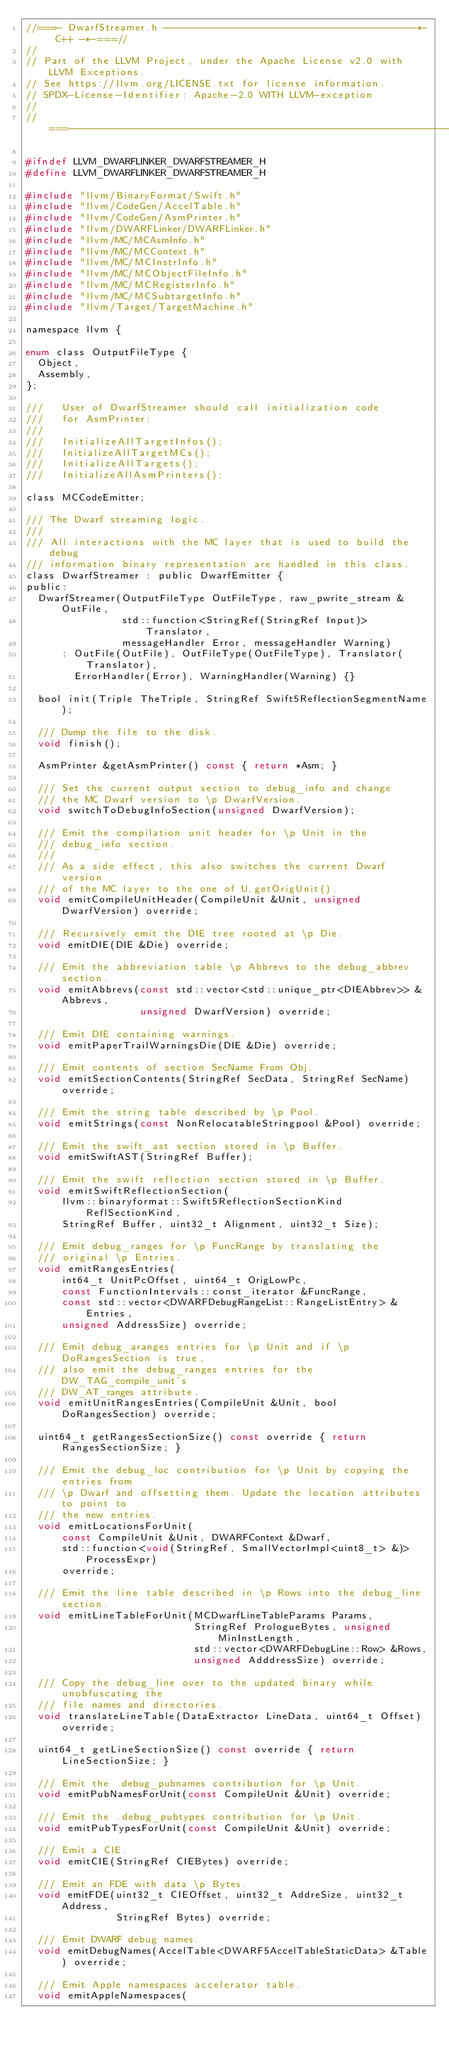Convert code to text. <code><loc_0><loc_0><loc_500><loc_500><_C_>//===- DwarfStreamer.h ------------------------------------------*- C++ -*-===//
//
// Part of the LLVM Project, under the Apache License v2.0 with LLVM Exceptions.
// See https://llvm.org/LICENSE.txt for license information.
// SPDX-License-Identifier: Apache-2.0 WITH LLVM-exception
//
//===----------------------------------------------------------------------===//

#ifndef LLVM_DWARFLINKER_DWARFSTREAMER_H
#define LLVM_DWARFLINKER_DWARFSTREAMER_H

#include "llvm/BinaryFormat/Swift.h"
#include "llvm/CodeGen/AccelTable.h"
#include "llvm/CodeGen/AsmPrinter.h"
#include "llvm/DWARFLinker/DWARFLinker.h"
#include "llvm/MC/MCAsmInfo.h"
#include "llvm/MC/MCContext.h"
#include "llvm/MC/MCInstrInfo.h"
#include "llvm/MC/MCObjectFileInfo.h"
#include "llvm/MC/MCRegisterInfo.h"
#include "llvm/MC/MCSubtargetInfo.h"
#include "llvm/Target/TargetMachine.h"

namespace llvm {

enum class OutputFileType {
  Object,
  Assembly,
};

///   User of DwarfStreamer should call initialization code
///   for AsmPrinter:
///
///   InitializeAllTargetInfos();
///   InitializeAllTargetMCs();
///   InitializeAllTargets();
///   InitializeAllAsmPrinters();

class MCCodeEmitter;

/// The Dwarf streaming logic.
///
/// All interactions with the MC layer that is used to build the debug
/// information binary representation are handled in this class.
class DwarfStreamer : public DwarfEmitter {
public:
  DwarfStreamer(OutputFileType OutFileType, raw_pwrite_stream &OutFile,
                std::function<StringRef(StringRef Input)> Translator,
                messageHandler Error, messageHandler Warning)
      : OutFile(OutFile), OutFileType(OutFileType), Translator(Translator),
        ErrorHandler(Error), WarningHandler(Warning) {}

  bool init(Triple TheTriple, StringRef Swift5ReflectionSegmentName);

  /// Dump the file to the disk.
  void finish();

  AsmPrinter &getAsmPrinter() const { return *Asm; }

  /// Set the current output section to debug_info and change
  /// the MC Dwarf version to \p DwarfVersion.
  void switchToDebugInfoSection(unsigned DwarfVersion);

  /// Emit the compilation unit header for \p Unit in the
  /// debug_info section.
  ///
  /// As a side effect, this also switches the current Dwarf version
  /// of the MC layer to the one of U.getOrigUnit().
  void emitCompileUnitHeader(CompileUnit &Unit, unsigned DwarfVersion) override;

  /// Recursively emit the DIE tree rooted at \p Die.
  void emitDIE(DIE &Die) override;

  /// Emit the abbreviation table \p Abbrevs to the debug_abbrev section.
  void emitAbbrevs(const std::vector<std::unique_ptr<DIEAbbrev>> &Abbrevs,
                   unsigned DwarfVersion) override;

  /// Emit DIE containing warnings.
  void emitPaperTrailWarningsDie(DIE &Die) override;

  /// Emit contents of section SecName From Obj.
  void emitSectionContents(StringRef SecData, StringRef SecName) override;

  /// Emit the string table described by \p Pool.
  void emitStrings(const NonRelocatableStringpool &Pool) override;

  /// Emit the swift_ast section stored in \p Buffer.
  void emitSwiftAST(StringRef Buffer);

  /// Emit the swift reflection section stored in \p Buffer.
  void emitSwiftReflectionSection(
      llvm::binaryformat::Swift5ReflectionSectionKind ReflSectionKind,
      StringRef Buffer, uint32_t Alignment, uint32_t Size);

  /// Emit debug_ranges for \p FuncRange by translating the
  /// original \p Entries.
  void emitRangesEntries(
      int64_t UnitPcOffset, uint64_t OrigLowPc,
      const FunctionIntervals::const_iterator &FuncRange,
      const std::vector<DWARFDebugRangeList::RangeListEntry> &Entries,
      unsigned AddressSize) override;

  /// Emit debug_aranges entries for \p Unit and if \p DoRangesSection is true,
  /// also emit the debug_ranges entries for the DW_TAG_compile_unit's
  /// DW_AT_ranges attribute.
  void emitUnitRangesEntries(CompileUnit &Unit, bool DoRangesSection) override;

  uint64_t getRangesSectionSize() const override { return RangesSectionSize; }

  /// Emit the debug_loc contribution for \p Unit by copying the entries from
  /// \p Dwarf and offsetting them. Update the location attributes to point to
  /// the new entries.
  void emitLocationsForUnit(
      const CompileUnit &Unit, DWARFContext &Dwarf,
      std::function<void(StringRef, SmallVectorImpl<uint8_t> &)> ProcessExpr)
      override;

  /// Emit the line table described in \p Rows into the debug_line section.
  void emitLineTableForUnit(MCDwarfLineTableParams Params,
                            StringRef PrologueBytes, unsigned MinInstLength,
                            std::vector<DWARFDebugLine::Row> &Rows,
                            unsigned AdddressSize) override;

  /// Copy the debug_line over to the updated binary while unobfuscating the
  /// file names and directories.
  void translateLineTable(DataExtractor LineData, uint64_t Offset) override;

  uint64_t getLineSectionSize() const override { return LineSectionSize; }

  /// Emit the .debug_pubnames contribution for \p Unit.
  void emitPubNamesForUnit(const CompileUnit &Unit) override;

  /// Emit the .debug_pubtypes contribution for \p Unit.
  void emitPubTypesForUnit(const CompileUnit &Unit) override;

  /// Emit a CIE.
  void emitCIE(StringRef CIEBytes) override;

  /// Emit an FDE with data \p Bytes.
  void emitFDE(uint32_t CIEOffset, uint32_t AddreSize, uint32_t Address,
               StringRef Bytes) override;

  /// Emit DWARF debug names.
  void emitDebugNames(AccelTable<DWARF5AccelTableStaticData> &Table) override;

  /// Emit Apple namespaces accelerator table.
  void emitAppleNamespaces(</code> 